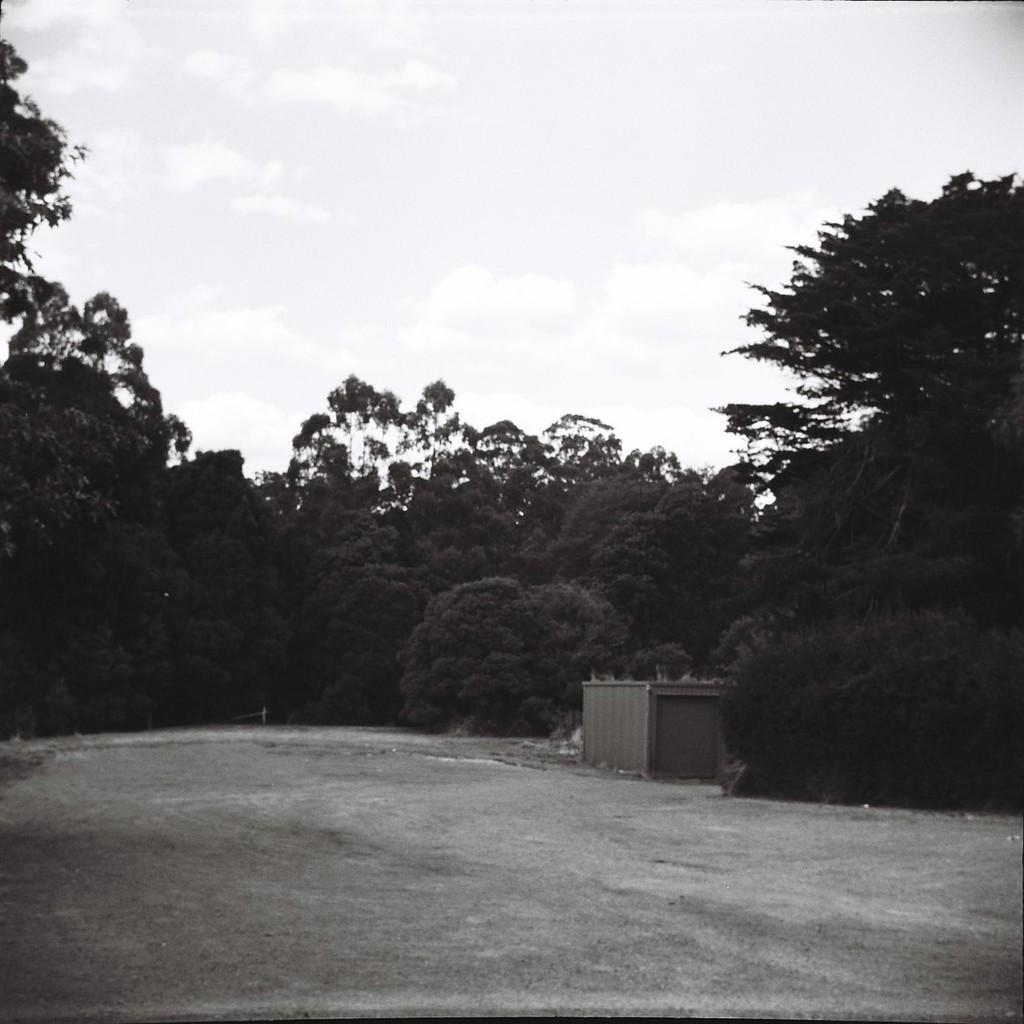In one or two sentences, can you explain what this image depicts? In this image we can see a shed placed on a ground. In the background we can see group of trees and sky. 